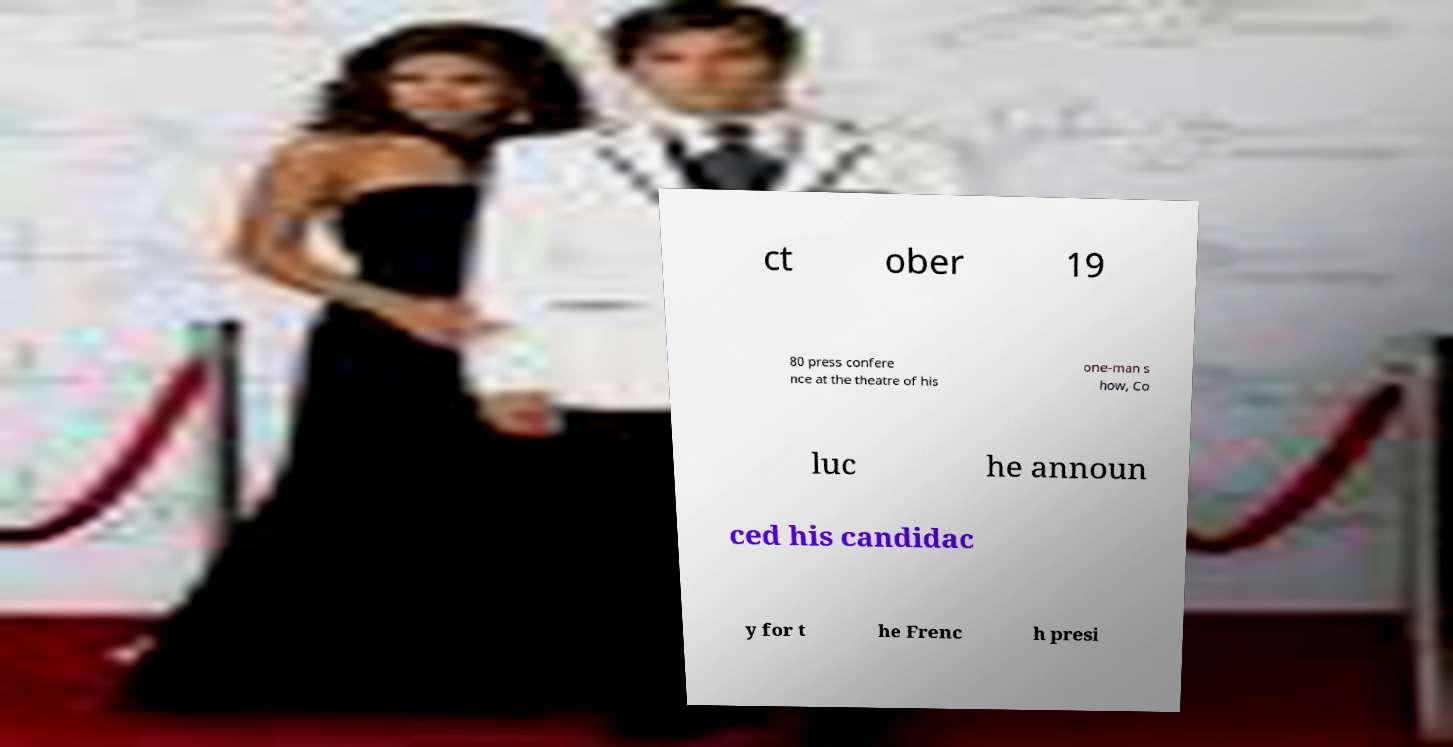I need the written content from this picture converted into text. Can you do that? ct ober 19 80 press confere nce at the theatre of his one-man s how, Co luc he announ ced his candidac y for t he Frenc h presi 